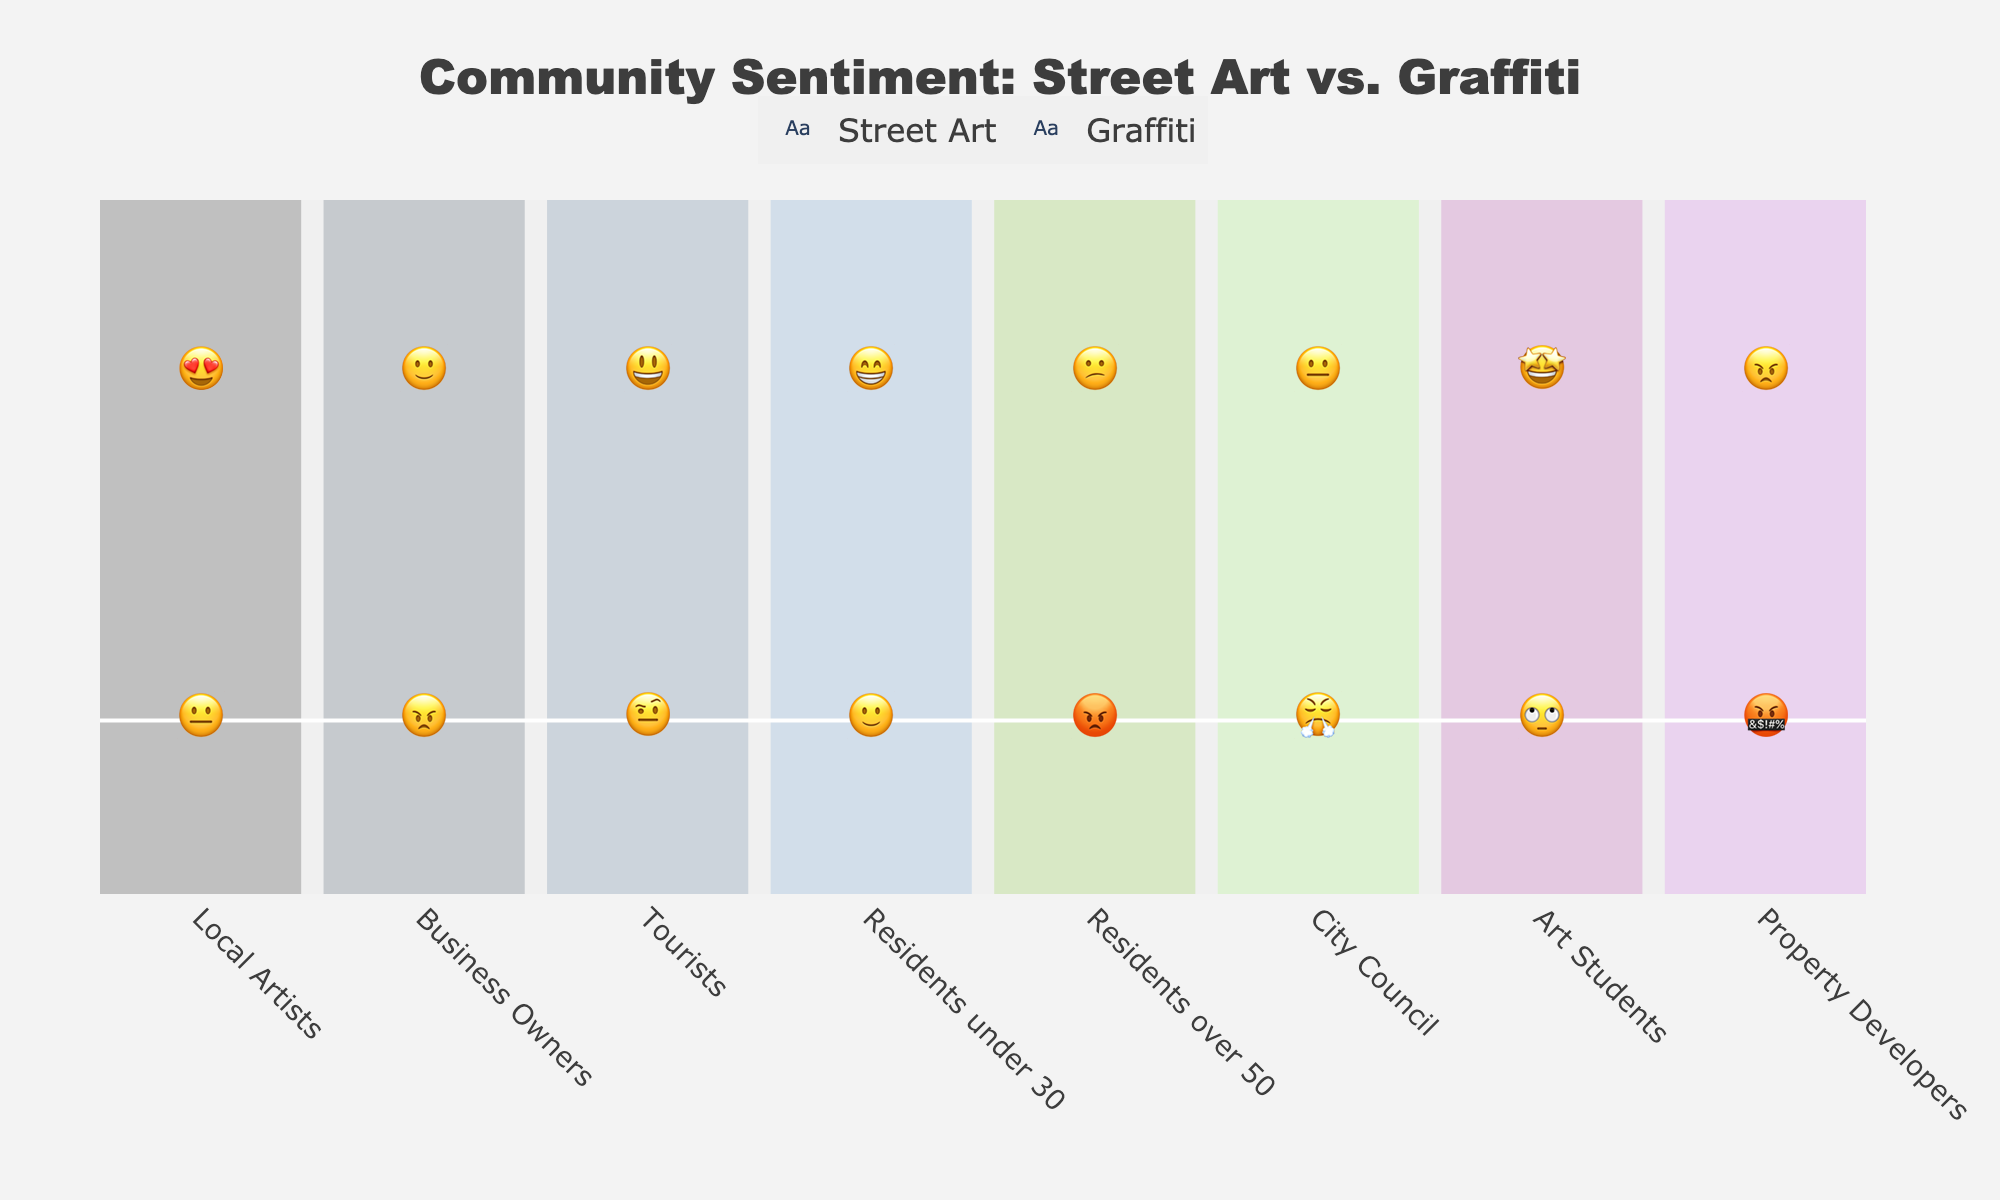What is the general sentiment of Business Owners towards Street Art? According to the chart, Business Owners have a 🙂 emoji next to Street Art, indicating a generally positive sentiment.
Answer: Positive (🙂) Which group has the most negative sentiment towards Graffiti? The Property Developers have the most negative emoji next to Graffiti (🤬), indicating extreme displeasure.
Answer: Property Developers (🤬) How do Residents under 30 feel about both Street Art and Graffiti? Residents under 30 are represented by 😁 for Street Art and 🙂 for Graffiti, indicating a positive sentiment towards both, but more positive towards Street Art.
Answer: 😁 for Street Art and 🙂 for Graffiti Which category is neutral towards both Street Art and Graffiti? The City Council has 😐 for Street Art and 😤 for Graffiti. Although 😤 is slightly negative, 😐 indicates neutrality, making them the closest to neutral feelings towards both.
Answer: City Council (😐, 😤) How does the sentiment of Local Artists towards Street Art compare to their sentiment towards Graffiti? Local Artists feel very positively towards Street Art (😍) and are neutral towards Graffiti (😐).
Answer: 😍 for Street Art and 😐 for Graffiti What is the sentiment of Art Students towards Graffiti? Art Students have a 🙄 emoji for Graffiti, indicating a negative sentiment.
Answer: Negative (🙄) Compare the sentiment of Residents over 50 and Residents under 30 towards Street Art. Residents under 30 have a 😁 emoji for Street Art, while Residents over 50 have a 😕 emoji, indicating that younger residents have a more positive sentiment than older residents.
Answer: 😁 (under 30) vs 😕 Which group has a mixed sentiment towards both types of art? Tourists have 😃 for Street Art (positive) and 🤨 for Graffiti (neutral/uncertain), indicating a mixed sentiment overall.
Answer: Tourists (😃, 🤨) For how many categories is the sentiment towards Street Art positive? Counting the positive responses (😍, 🙂, 😃, 😁, 🤩), there are 5 categories with positive sentiment towards Street Art: Local Artists, Business Owners, Tourists, Residents under 30, and Art Students.
Answer: 5 What group shows the greatest disparity between their sentiment towards Street Art and Graffiti? Property Developers show the greatest disparity with 😠 for Street Art (negative) and 🤬 for Graffiti (very negative), indicating a strong dislike for both, but more for Graffiti.
Answer: Property Developers (😠, 🤬) 